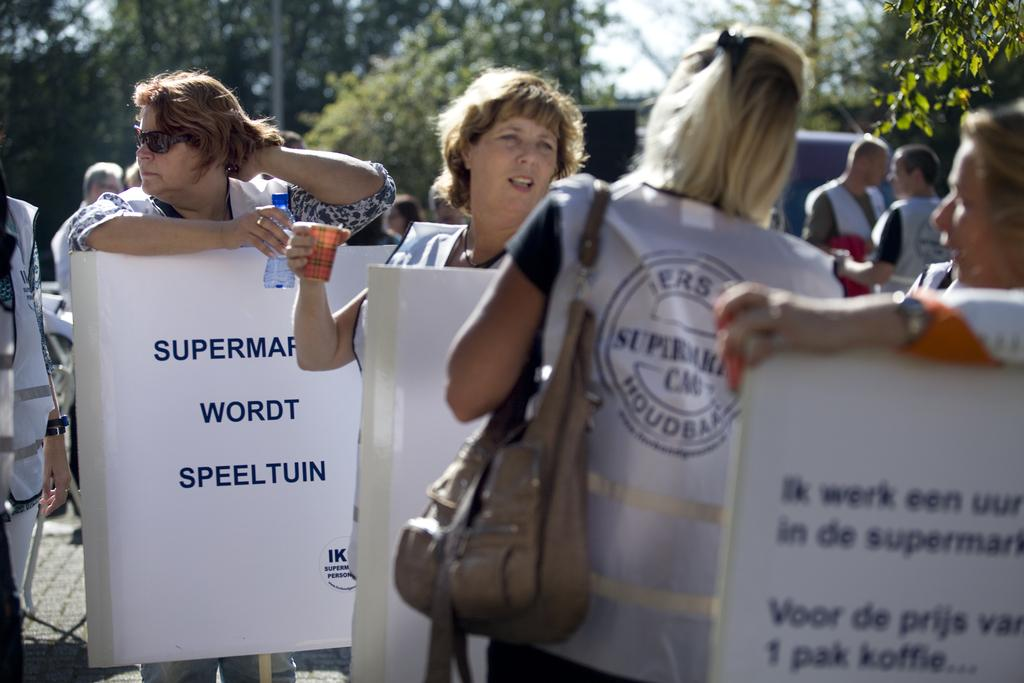How many people are in the image? There is a group of people in the image. What are the people holding in the image? The people are holding boards in the image. Is there anyone holding an object other than a board? Yes, there is a person holding a bottle in the image. What can be seen in the background of the image? There are trees and the sky visible in the background of the image. Can you tell me how many babies are in the image? There is no baby present in the image. Is there a rainstorm happening in the image? There is no indication of a rainstorm in the image; the sky is visible and appears clear. 